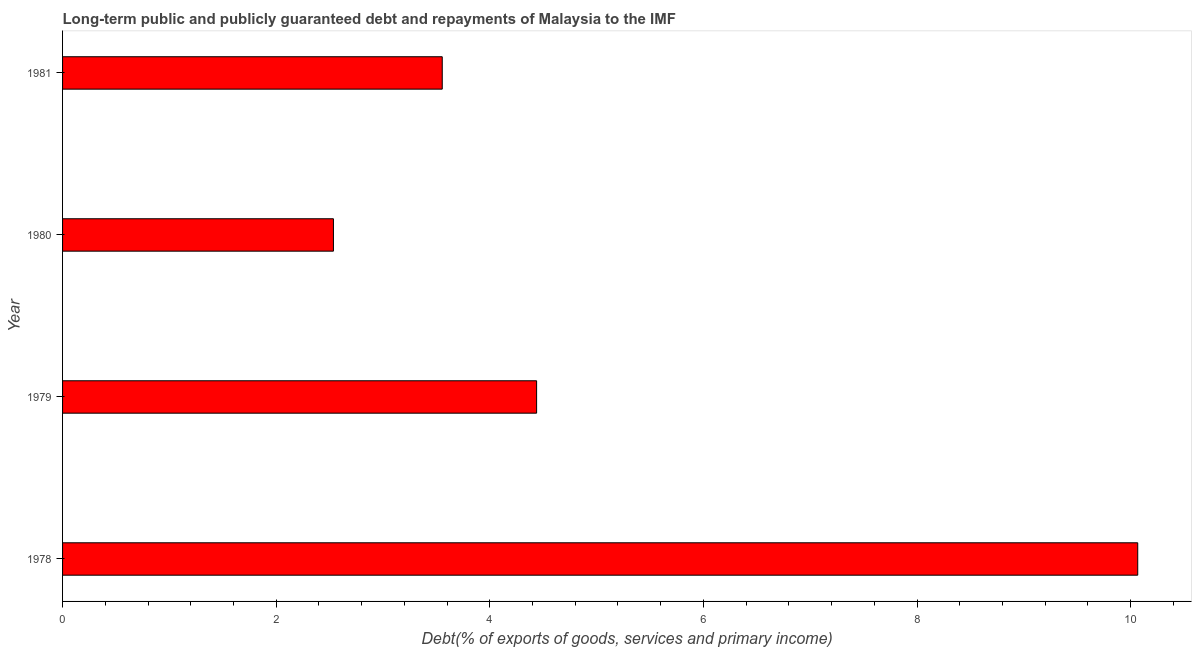Does the graph contain any zero values?
Offer a terse response. No. What is the title of the graph?
Your response must be concise. Long-term public and publicly guaranteed debt and repayments of Malaysia to the IMF. What is the label or title of the X-axis?
Your response must be concise. Debt(% of exports of goods, services and primary income). What is the label or title of the Y-axis?
Offer a terse response. Year. What is the debt service in 1980?
Ensure brevity in your answer.  2.54. Across all years, what is the maximum debt service?
Give a very brief answer. 10.07. Across all years, what is the minimum debt service?
Provide a short and direct response. 2.54. In which year was the debt service maximum?
Your answer should be compact. 1978. In which year was the debt service minimum?
Your answer should be very brief. 1980. What is the sum of the debt service?
Your response must be concise. 20.6. What is the difference between the debt service in 1978 and 1981?
Provide a short and direct response. 6.51. What is the average debt service per year?
Ensure brevity in your answer.  5.15. What is the median debt service?
Provide a succinct answer. 4. In how many years, is the debt service greater than 6.4 %?
Provide a short and direct response. 1. What is the ratio of the debt service in 1979 to that in 1981?
Offer a terse response. 1.25. Is the debt service in 1979 less than that in 1980?
Provide a succinct answer. No. What is the difference between the highest and the second highest debt service?
Ensure brevity in your answer.  5.63. What is the difference between the highest and the lowest debt service?
Make the answer very short. 7.53. In how many years, is the debt service greater than the average debt service taken over all years?
Keep it short and to the point. 1. Are all the bars in the graph horizontal?
Keep it short and to the point. Yes. What is the difference between two consecutive major ticks on the X-axis?
Make the answer very short. 2. What is the Debt(% of exports of goods, services and primary income) of 1978?
Ensure brevity in your answer.  10.07. What is the Debt(% of exports of goods, services and primary income) of 1979?
Offer a very short reply. 4.44. What is the Debt(% of exports of goods, services and primary income) of 1980?
Provide a succinct answer. 2.54. What is the Debt(% of exports of goods, services and primary income) in 1981?
Offer a very short reply. 3.55. What is the difference between the Debt(% of exports of goods, services and primary income) in 1978 and 1979?
Your answer should be compact. 5.63. What is the difference between the Debt(% of exports of goods, services and primary income) in 1978 and 1980?
Keep it short and to the point. 7.53. What is the difference between the Debt(% of exports of goods, services and primary income) in 1978 and 1981?
Provide a short and direct response. 6.51. What is the difference between the Debt(% of exports of goods, services and primary income) in 1979 and 1980?
Your answer should be compact. 1.9. What is the difference between the Debt(% of exports of goods, services and primary income) in 1979 and 1981?
Your answer should be compact. 0.88. What is the difference between the Debt(% of exports of goods, services and primary income) in 1980 and 1981?
Provide a short and direct response. -1.02. What is the ratio of the Debt(% of exports of goods, services and primary income) in 1978 to that in 1979?
Your response must be concise. 2.27. What is the ratio of the Debt(% of exports of goods, services and primary income) in 1978 to that in 1980?
Provide a short and direct response. 3.97. What is the ratio of the Debt(% of exports of goods, services and primary income) in 1978 to that in 1981?
Provide a succinct answer. 2.83. What is the ratio of the Debt(% of exports of goods, services and primary income) in 1979 to that in 1981?
Your answer should be very brief. 1.25. What is the ratio of the Debt(% of exports of goods, services and primary income) in 1980 to that in 1981?
Provide a short and direct response. 0.71. 